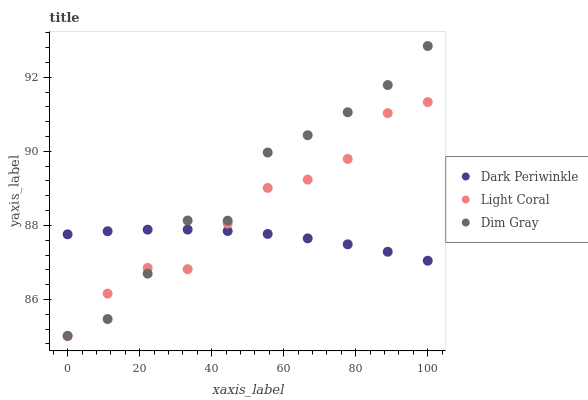Does Dark Periwinkle have the minimum area under the curve?
Answer yes or no. Yes. Does Dim Gray have the maximum area under the curve?
Answer yes or no. Yes. Does Dim Gray have the minimum area under the curve?
Answer yes or no. No. Does Dark Periwinkle have the maximum area under the curve?
Answer yes or no. No. Is Dark Periwinkle the smoothest?
Answer yes or no. Yes. Is Dim Gray the roughest?
Answer yes or no. Yes. Is Dim Gray the smoothest?
Answer yes or no. No. Is Dark Periwinkle the roughest?
Answer yes or no. No. Does Light Coral have the lowest value?
Answer yes or no. Yes. Does Dim Gray have the lowest value?
Answer yes or no. No. Does Dim Gray have the highest value?
Answer yes or no. Yes. Does Dark Periwinkle have the highest value?
Answer yes or no. No. Does Dark Periwinkle intersect Light Coral?
Answer yes or no. Yes. Is Dark Periwinkle less than Light Coral?
Answer yes or no. No. Is Dark Periwinkle greater than Light Coral?
Answer yes or no. No. 